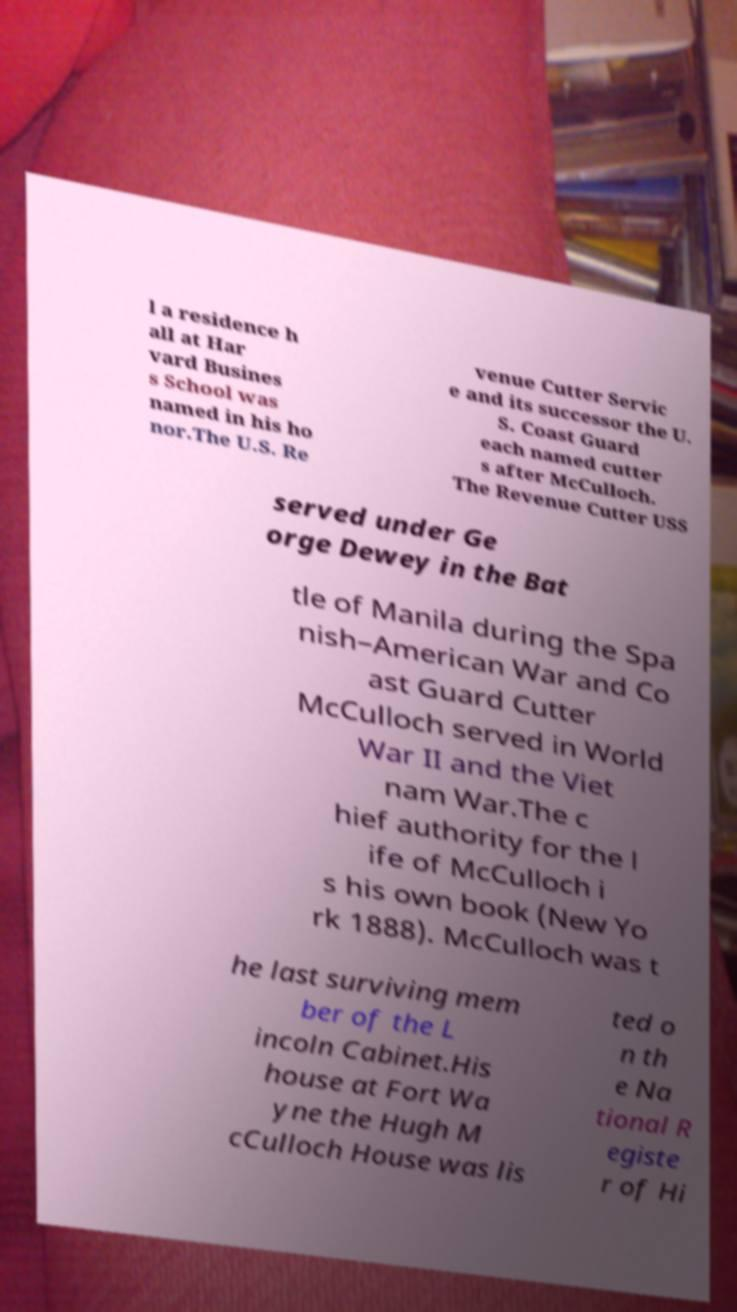Could you assist in decoding the text presented in this image and type it out clearly? l a residence h all at Har vard Busines s School was named in his ho nor.The U.S. Re venue Cutter Servic e and its successor the U. S. Coast Guard each named cutter s after McCulloch. The Revenue Cutter USS served under Ge orge Dewey in the Bat tle of Manila during the Spa nish–American War and Co ast Guard Cutter McCulloch served in World War II and the Viet nam War.The c hief authority for the l ife of McCulloch i s his own book (New Yo rk 1888). McCulloch was t he last surviving mem ber of the L incoln Cabinet.His house at Fort Wa yne the Hugh M cCulloch House was lis ted o n th e Na tional R egiste r of Hi 